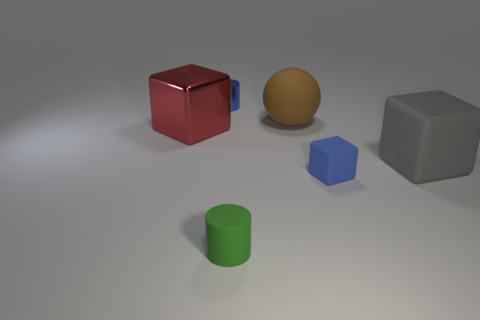Is there anything else that is the same size as the red thing?
Ensure brevity in your answer.  Yes. How many things are either large red rubber objects or things that are in front of the small metal cylinder?
Offer a very short reply. 5. There is a cylinder that is behind the large metallic thing; does it have the same size as the cylinder right of the tiny shiny object?
Your answer should be very brief. Yes. How many other things are there of the same color as the metallic cylinder?
Give a very brief answer. 1. Does the brown ball have the same size as the blue thing that is right of the blue cylinder?
Ensure brevity in your answer.  No. There is a cylinder that is on the right side of the shiny object right of the big red metal object; what is its size?
Make the answer very short. Small. There is a large matte thing that is the same shape as the large metal thing; what color is it?
Ensure brevity in your answer.  Gray. Is the size of the red metal cube the same as the matte sphere?
Give a very brief answer. Yes. Is the number of small matte cylinders that are to the left of the blue metal thing the same as the number of balls?
Provide a short and direct response. No. There is a shiny object in front of the blue metallic cylinder; are there any large metallic things behind it?
Ensure brevity in your answer.  No. 